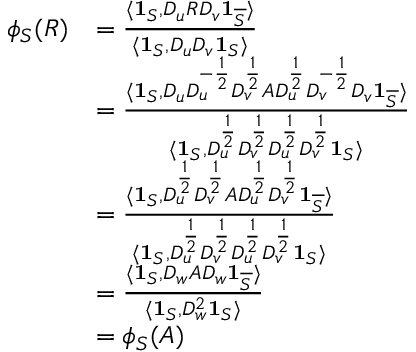<formula> <loc_0><loc_0><loc_500><loc_500>\begin{array} { r l } { \phi _ { S } ( R ) } & { = \frac { \langle 1 _ { S } , D _ { u } R D _ { v } 1 _ { \overline { S } } \rangle } { \langle 1 _ { S } , D _ { u } D _ { v } 1 _ { S } \rangle } } \\ & { = \frac { \langle 1 _ { S } , D _ { u } D _ { u } ^ { - \frac { 1 } { 2 } } D _ { v } ^ { \frac { 1 } { 2 } } A D _ { u } ^ { \frac { 1 } { 2 } } D _ { v } ^ { - \frac { 1 } { 2 } } D _ { v } 1 _ { \overline { S } } \rangle } { \langle 1 _ { S } , D _ { u } ^ { \frac { 1 } { 2 } } D _ { v } ^ { \frac { 1 } { 2 } } D _ { u } ^ { \frac { 1 } { 2 } } D _ { v } ^ { \frac { 1 } { 2 } } 1 _ { S } \rangle } } \\ & { = \frac { \langle 1 _ { S } , D _ { u } ^ { \frac { 1 } { 2 } } D _ { v } ^ { \frac { 1 } { 2 } } A D _ { u } ^ { \frac { 1 } { 2 } } D _ { v } ^ { \frac { 1 } { 2 } } 1 _ { \overline { S } } \rangle } { \langle 1 _ { S } , D _ { u } ^ { \frac { 1 } { 2 } } D _ { v } ^ { \frac { 1 } { 2 } } D _ { u } ^ { \frac { 1 } { 2 } } D _ { v } ^ { \frac { 1 } { 2 } } 1 _ { S } \rangle } } \\ & { = \frac { \langle 1 _ { S } , D _ { w } A D _ { w } 1 _ { \overline { S } } \rangle } { \langle 1 _ { S } , D _ { w } ^ { 2 } 1 _ { S } \rangle } } \\ & { = \phi _ { S } ( A ) } \end{array}</formula> 